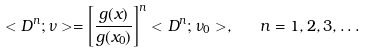<formula> <loc_0><loc_0><loc_500><loc_500>< D ^ { n } ; \nu > = \left [ \frac { g ( x ) } { g ( x _ { 0 } ) } \right ] ^ { n } < D ^ { n } ; \nu _ { 0 } > , \quad n = 1 , 2 , 3 , \dots</formula> 